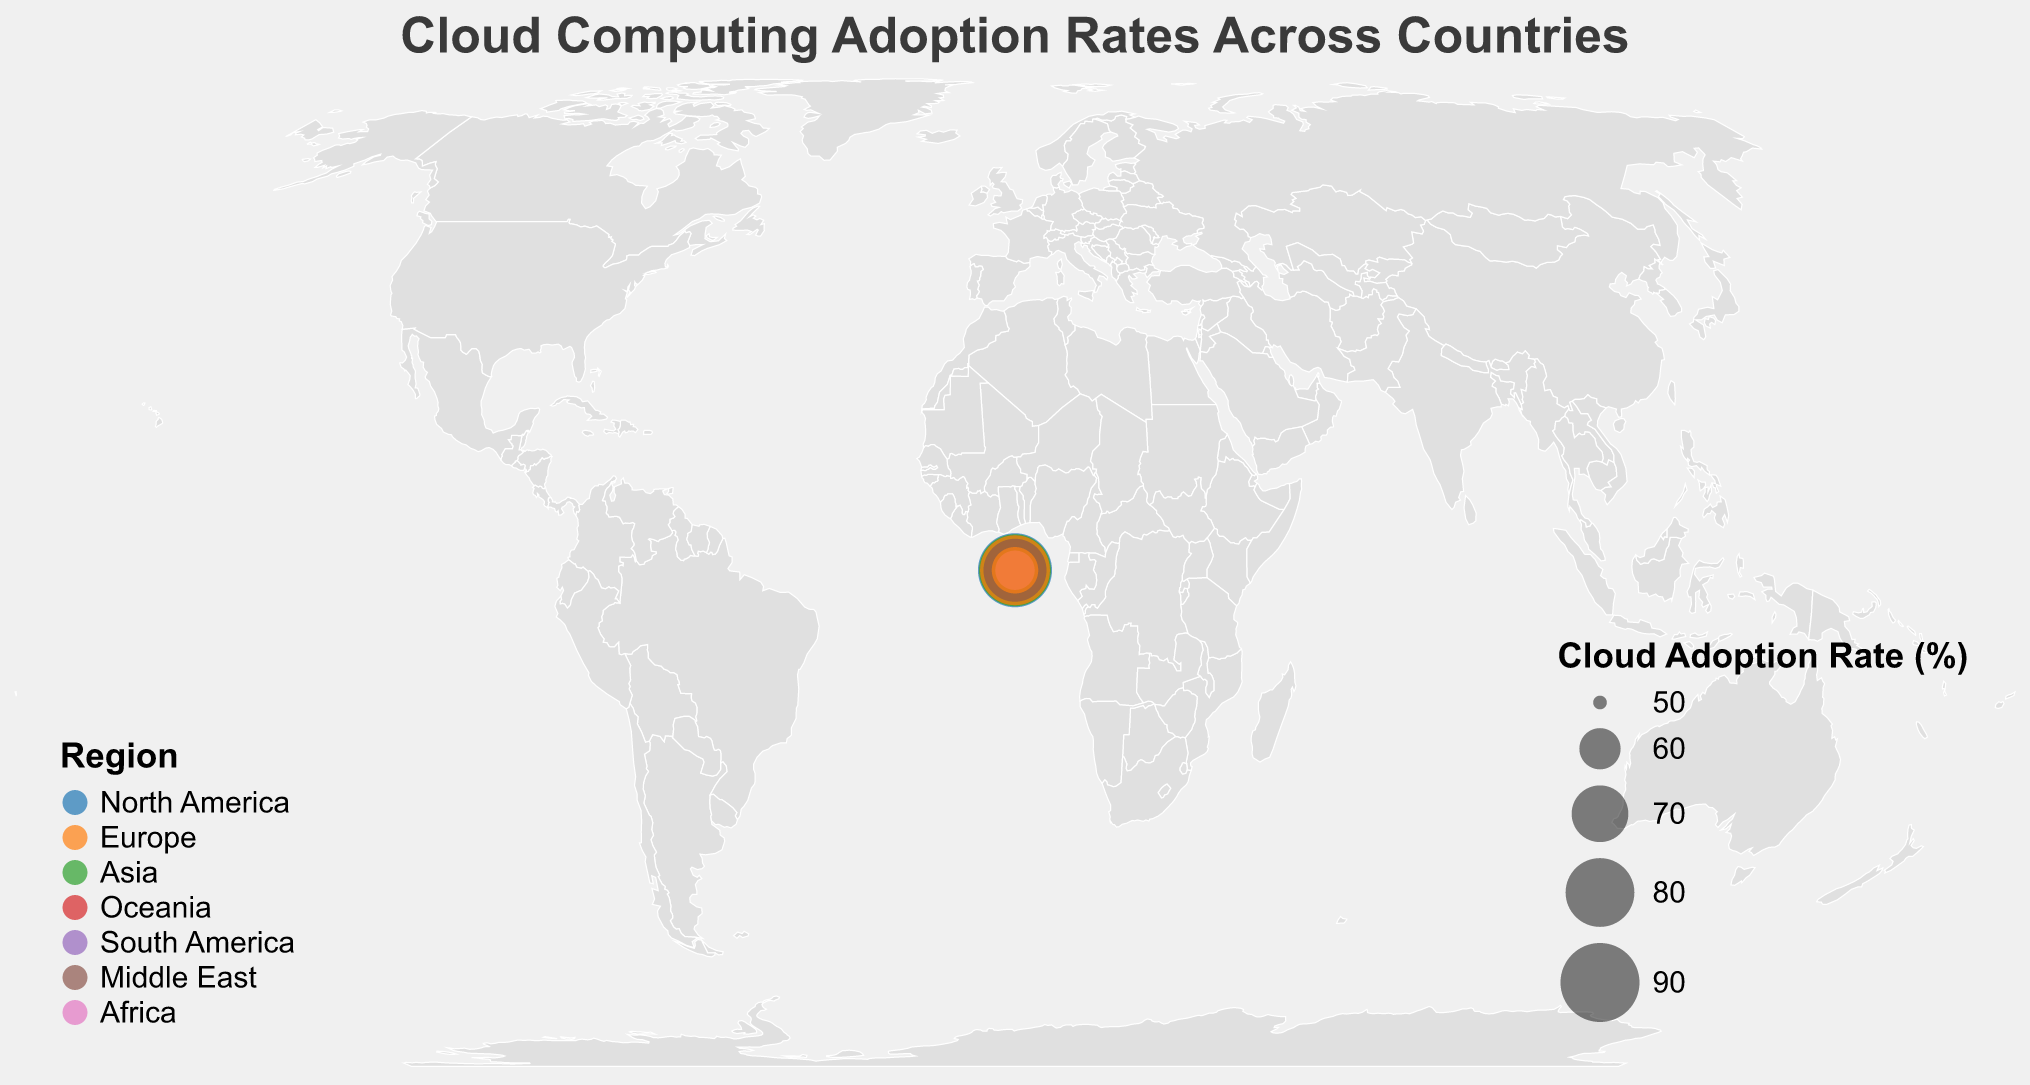What country has the highest cloud adoption rate? By observing the largest circle on the plot, which would represent the highest cloud adoption rate, we can identify the country with the highest rate. According to the data, the largest circle represents the United States with an adoption rate of 85%.
Answer: United States Which region has the lowest cloud adoption rate, and what is the rate? By comparing the smallest circles color-coded by region, we can see that the smallest circle representing a specific region belongs to Africa, with a cloud adoption rate of 59% in South Africa.
Answer: Africa, 59% What is the average cloud adoption rate in Europe? Sum the adoption rates for European countries: (82 + 76 + 72 + 70 + 67 + 79 + 81 + 63) = 590, then divide by the number of European countries, which is 8. 590 / 8 = 73.75.
Answer: 73.75 How does the cloud adoption rate in Australia compare to that in Japan? By comparing the rates for Australia (80%) and Japan (79%) directly from the visual circles and based on the data. Australia has a slightly higher cloud adoption rate than Japan by 1%.
Answer: Australia has a higher rate Which country in Asia has the highest cloud adoption rate? By observing the colored circles representing Asian countries and identifying the largest circle. According to the data, Singapore has the highest cloud adoption rate in Asia at 83%.
Answer: Singapore What is the difference in cloud adoption rates between the United States and Mexico? Subtract Mexico's cloud adoption rate (62%) from the United States' rate (85%) to get the difference. 85 - 62 = 23.
Answer: 23 Identify two countries with the closest cloud adoption rates and their values. By visually comparing the sizes of the circles, two countries with close adoption rates are Germany (76%) and South Korea (77%), having a difference of only 1%.
Answer: Germany (76%) and South Korea (77%) Which regions have countries with cloud adoption rates above 80%? By filtering the circles that correspond to rates above 80%, we see they belong to North America, Europe, and Asia. The countries are the United States (85%), United Kingdom (82%), Singapore (83%), and Sweden (81%).
Answer: North America, Europe, Asia What is the combined cloud adoption rate for North American countries? Add the cloud adoption rates of the United States (85%), Canada (78%), and Mexico (62%). 85 + 78 + 62 = 225.
Answer: 225 Is there any country in the Middle East with a cloud adoption rate higher than 75%? Observing the circles and referencing the data, the United Arab Emirates is the only country from the Middle East shown, and its adoption rate is exactly 75%, hence no country exceeds this rate in the Middle East.
Answer: No 